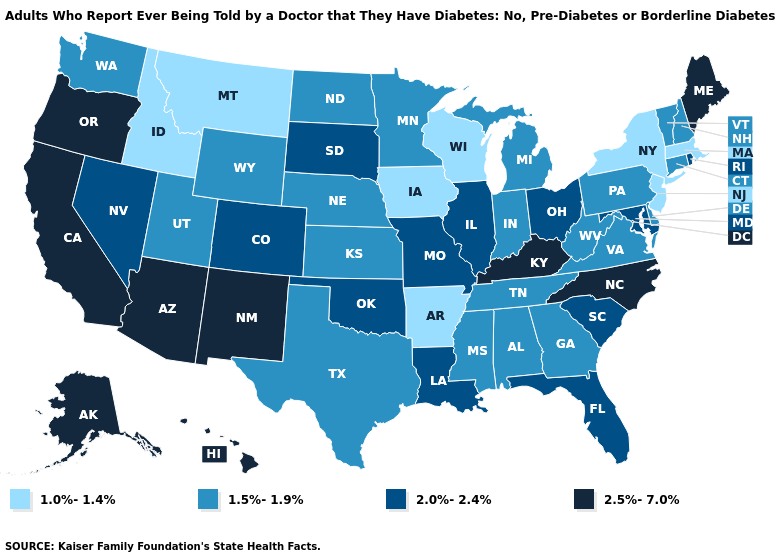Among the states that border Pennsylvania , does New Jersey have the lowest value?
Be succinct. Yes. What is the value of Vermont?
Keep it brief. 1.5%-1.9%. What is the highest value in the West ?
Keep it brief. 2.5%-7.0%. What is the lowest value in the MidWest?
Concise answer only. 1.0%-1.4%. What is the highest value in the USA?
Short answer required. 2.5%-7.0%. Does Alabama have the lowest value in the USA?
Quick response, please. No. What is the lowest value in the South?
Give a very brief answer. 1.0%-1.4%. Name the states that have a value in the range 2.0%-2.4%?
Write a very short answer. Colorado, Florida, Illinois, Louisiana, Maryland, Missouri, Nevada, Ohio, Oklahoma, Rhode Island, South Carolina, South Dakota. Which states have the highest value in the USA?
Concise answer only. Alaska, Arizona, California, Hawaii, Kentucky, Maine, New Mexico, North Carolina, Oregon. Name the states that have a value in the range 1.0%-1.4%?
Short answer required. Arkansas, Idaho, Iowa, Massachusetts, Montana, New Jersey, New York, Wisconsin. Does Delaware have the lowest value in the South?
Give a very brief answer. No. Does the map have missing data?
Give a very brief answer. No. Does the map have missing data?
Be succinct. No. What is the value of Florida?
Answer briefly. 2.0%-2.4%. Does the map have missing data?
Short answer required. No. 